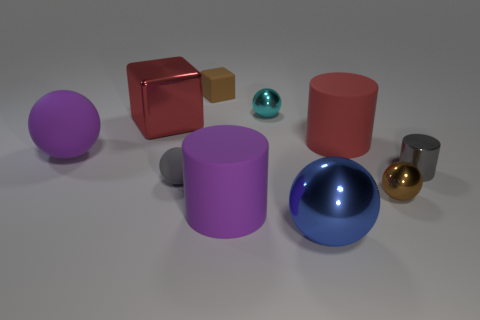Is the number of gray balls greater than the number of small yellow metal things?
Your response must be concise. Yes. How many matte objects are green things or red blocks?
Give a very brief answer. 0. What number of matte cylinders have the same color as the metallic block?
Provide a succinct answer. 1. What is the material of the brown object that is on the right side of the thing that is in front of the large matte cylinder in front of the small gray cylinder?
Provide a short and direct response. Metal. The block in front of the rubber object behind the small cyan sphere is what color?
Give a very brief answer. Red. How many large things are brown metallic balls or blue spheres?
Give a very brief answer. 1. How many big things have the same material as the small cyan ball?
Ensure brevity in your answer.  2. There is a rubber sphere in front of the small gray shiny object; how big is it?
Your answer should be very brief. Small. There is a red object left of the matte cylinder that is behind the brown metal object; what is its shape?
Ensure brevity in your answer.  Cube. What number of blue shiny objects are behind the sphere that is behind the big purple rubber ball in front of the large red metal cube?
Ensure brevity in your answer.  0. 